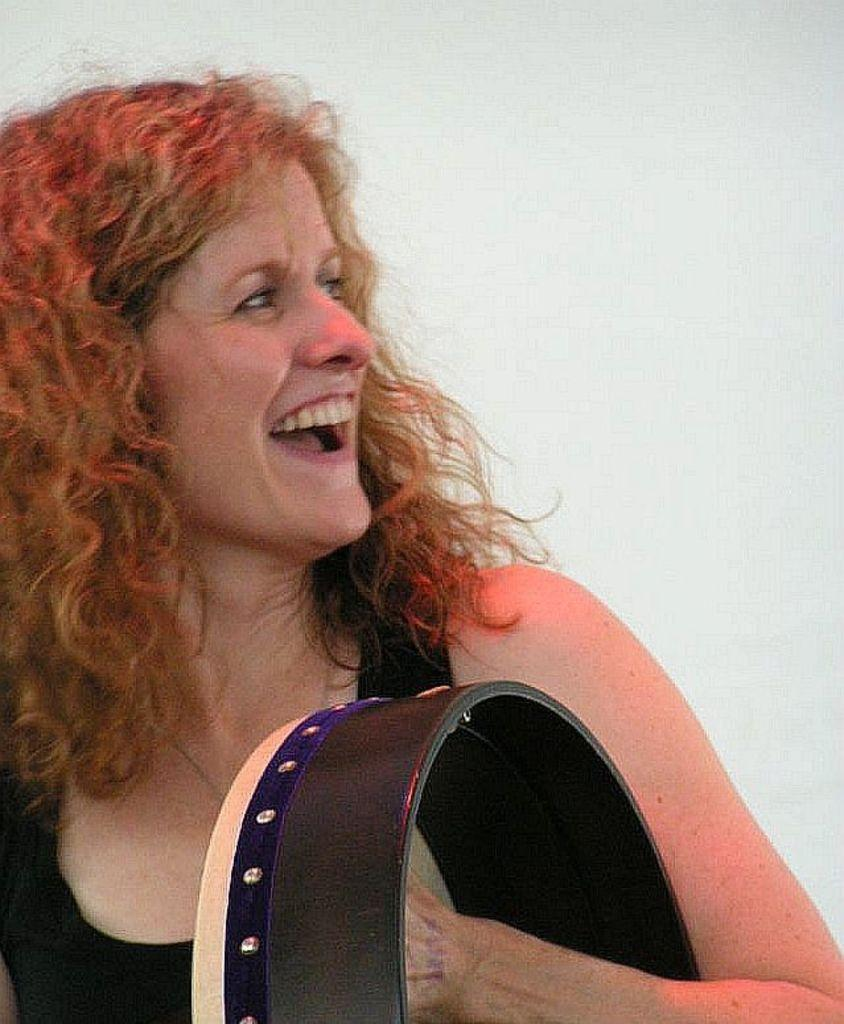Who is present in the image? There is a lady in the image. What is the lady holding in the image? The lady is holding something. What is the lady's facial expression in the image? The lady is smiling. What can be seen in the background of the image? There is a white color wall in the background of the image. Is there an earthquake happening in the image? No, there is no indication of an earthquake in the image. 